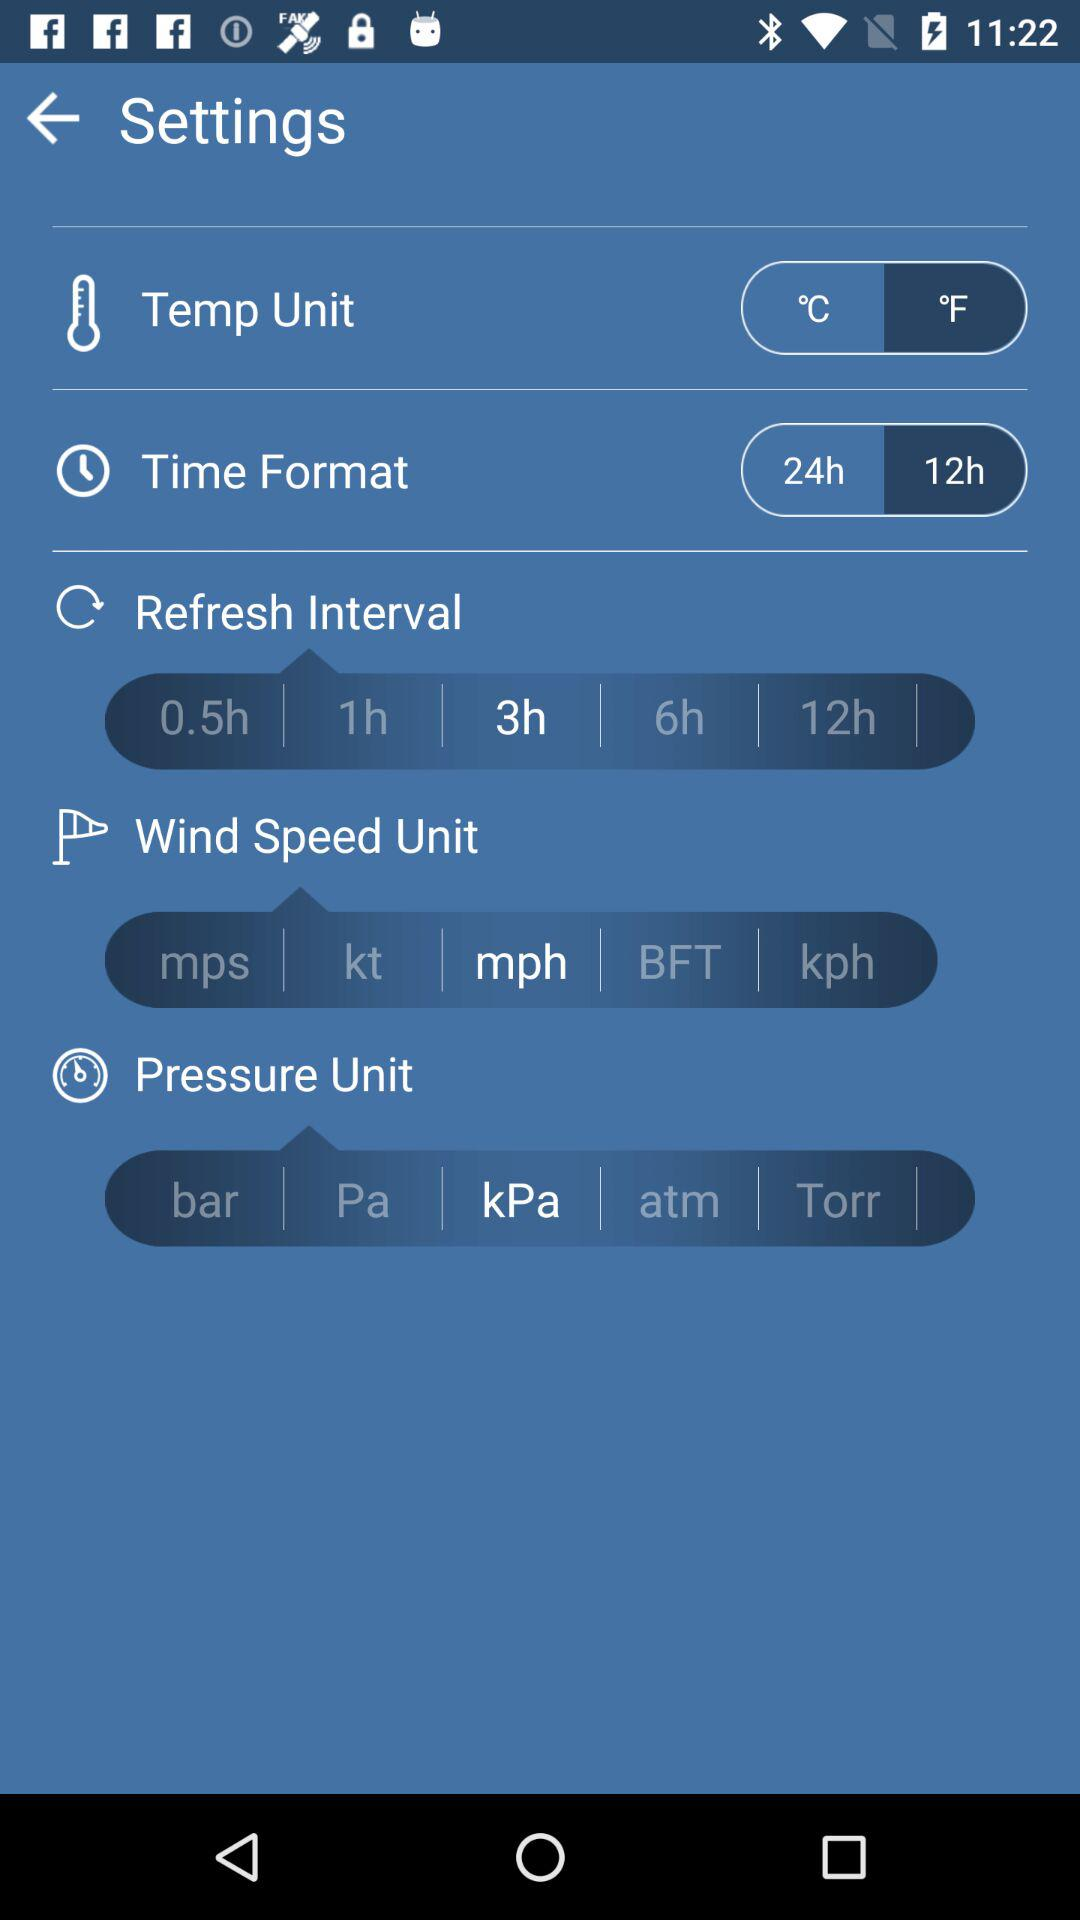Which option is selected for the refresh interval? The selected option is "3h". 